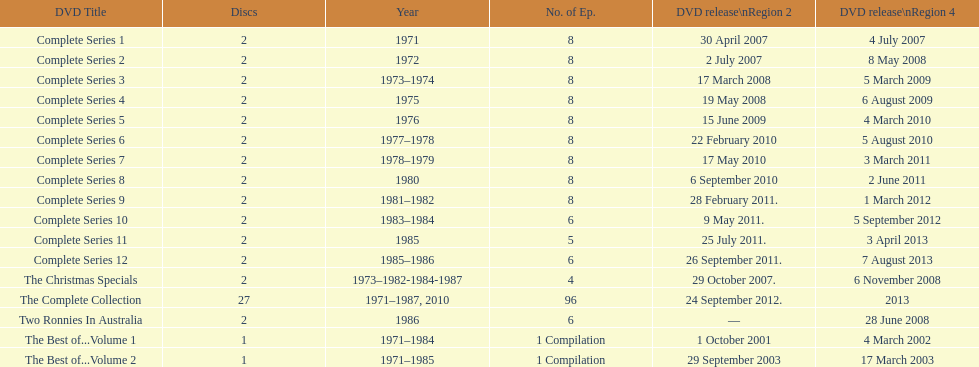Dvds with fewer than 5 episodes The Christmas Specials. 